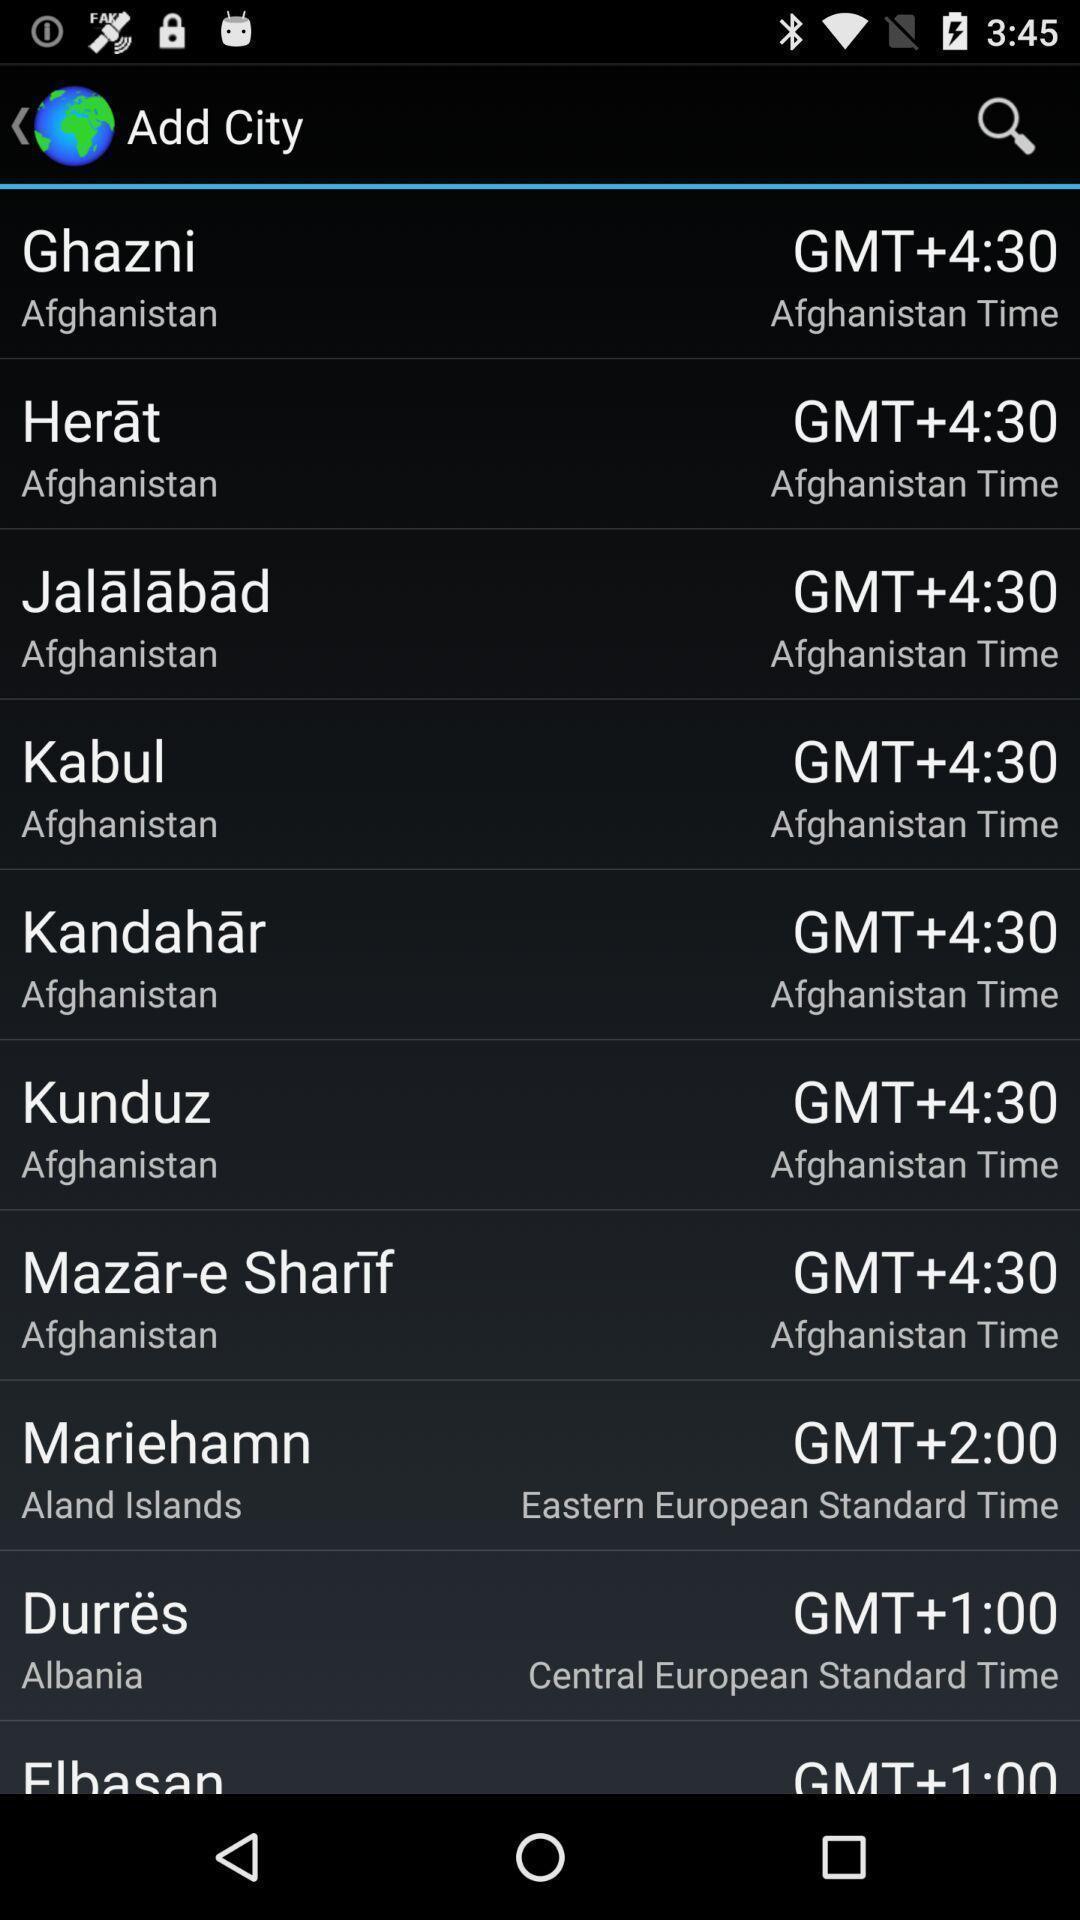Describe this image in words. Page that displaying time of all countries. 